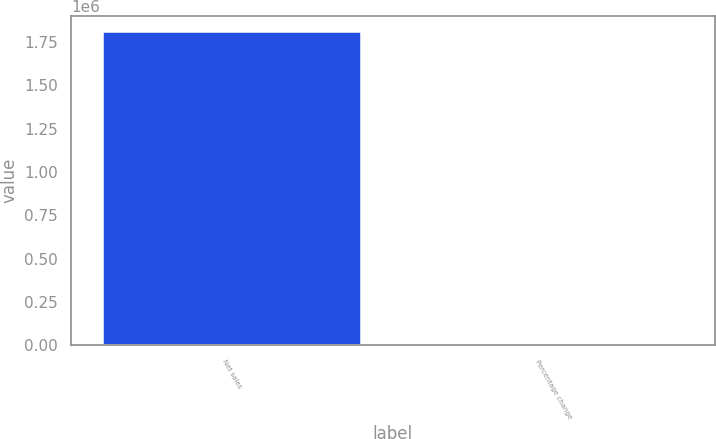Convert chart to OTSL. <chart><loc_0><loc_0><loc_500><loc_500><bar_chart><fcel>Net sales<fcel>Percentage change<nl><fcel>1.80934e+06<fcel>18.8<nl></chart> 